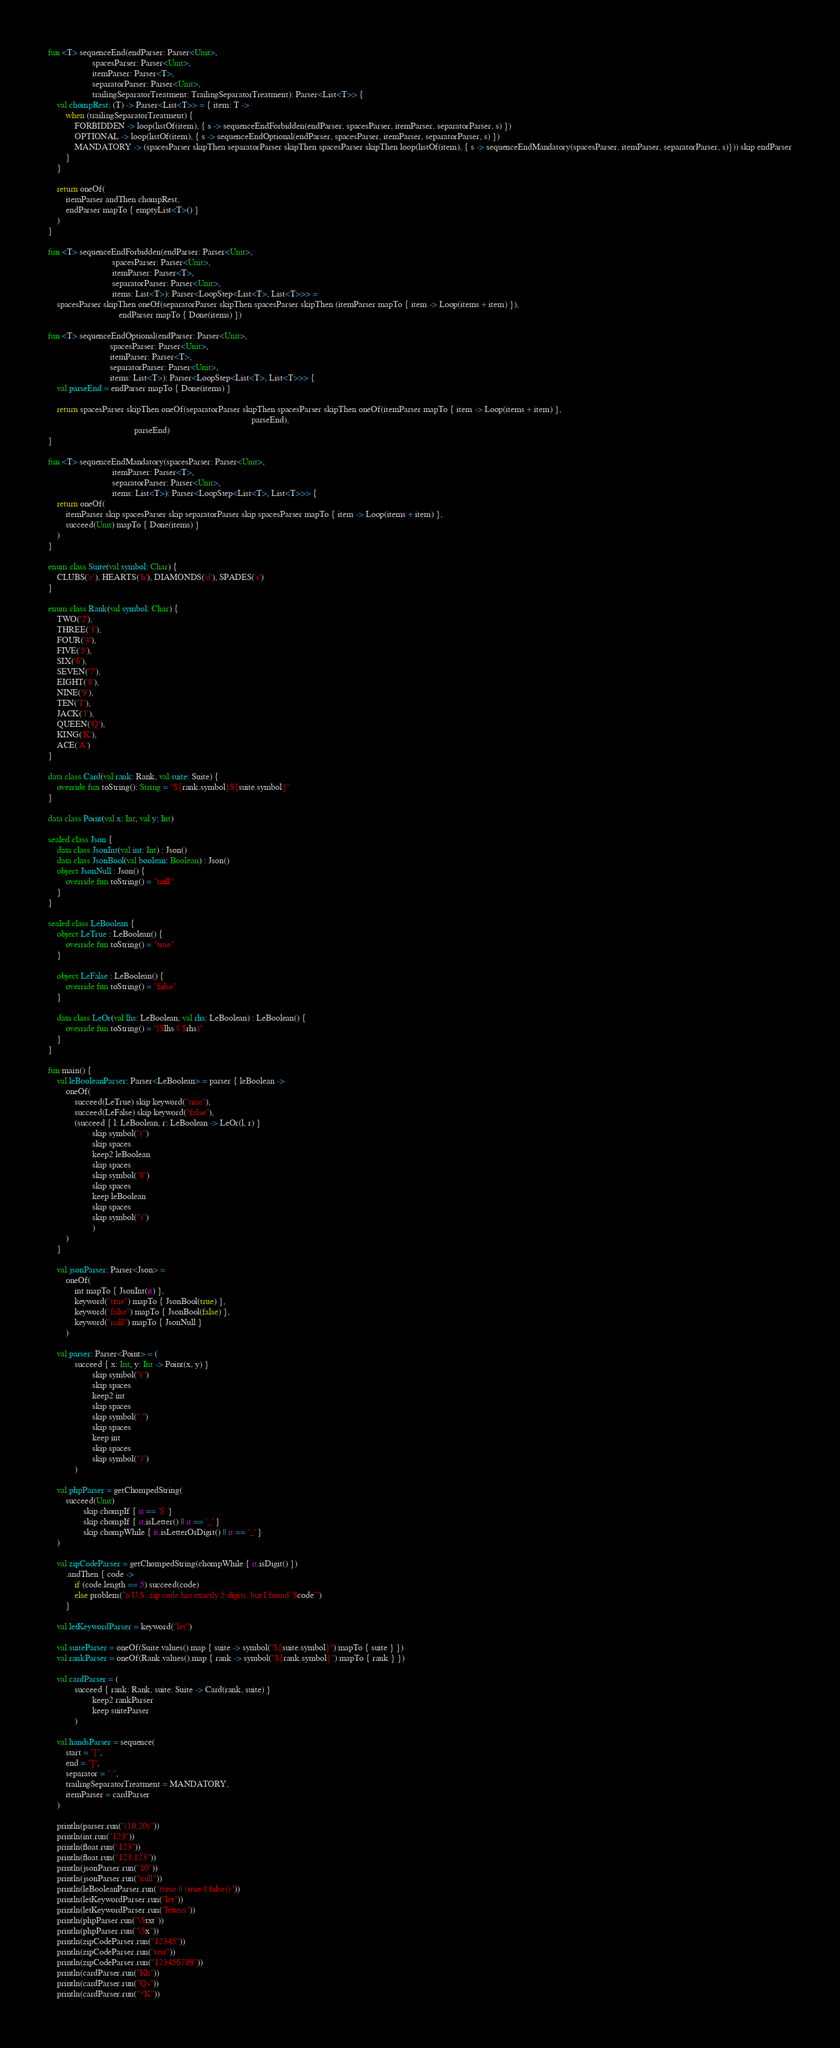<code> <loc_0><loc_0><loc_500><loc_500><_Kotlin_>fun <T> sequenceEnd(endParser: Parser<Unit>,
                    spacesParser: Parser<Unit>,
                    itemParser: Parser<T>,
                    separatorParser: Parser<Unit>,
                    trailingSeparatorTreatment: TrailingSeparatorTreatment): Parser<List<T>> {
    val chompRest: (T) -> Parser<List<T>> = { item: T ->
        when (trailingSeparatorTreatment) {
            FORBIDDEN -> loop(listOf(item), { s -> sequenceEndForbidden(endParser, spacesParser, itemParser, separatorParser, s) })
            OPTIONAL -> loop(listOf(item), { s -> sequenceEndOptional(endParser, spacesParser, itemParser, separatorParser, s) })
            MANDATORY -> (spacesParser skipThen separatorParser skipThen spacesParser skipThen loop(listOf(item), { s -> sequenceEndMandatory(spacesParser, itemParser, separatorParser, s)})) skip endParser
        }
    }

    return oneOf(
        itemParser andThen chompRest,
        endParser mapTo { emptyList<T>() }
    )
}

fun <T> sequenceEndForbidden(endParser: Parser<Unit>,
                             spacesParser: Parser<Unit>,
                             itemParser: Parser<T>,
                             separatorParser: Parser<Unit>,
                             items: List<T>): Parser<LoopStep<List<T>, List<T>>> =
    spacesParser skipThen oneOf(separatorParser skipThen spacesParser skipThen (itemParser mapTo { item -> Loop(items + item) }),
                                endParser mapTo { Done(items) })

fun <T> sequenceEndOptional(endParser: Parser<Unit>,
                            spacesParser: Parser<Unit>,
                            itemParser: Parser<T>,
                            separatorParser: Parser<Unit>,
                            items: List<T>): Parser<LoopStep<List<T>, List<T>>> {
    val parseEnd = endParser mapTo { Done(items) }

    return spacesParser skipThen oneOf(separatorParser skipThen spacesParser skipThen oneOf(itemParser mapTo { item -> Loop(items + item) },
                                                                                            parseEnd),
                                       parseEnd)
}

fun <T> sequenceEndMandatory(spacesParser: Parser<Unit>,
                             itemParser: Parser<T>,
                             separatorParser: Parser<Unit>,
                             items: List<T>): Parser<LoopStep<List<T>, List<T>>> {
    return oneOf(
        itemParser skip spacesParser skip separatorParser skip spacesParser mapTo { item -> Loop(items + item) },
        succeed(Unit) mapTo { Done(items) }
    )
}

enum class Suite(val symbol: Char) {
    CLUBS('c'), HEARTS('h'), DIAMONDS('d'), SPADES('s')
}

enum class Rank(val symbol: Char) {
    TWO('2'),
    THREE('3'),
    FOUR('4'),
    FIVE('5'),
    SIX('6'),
    SEVEN('7'),
    EIGHT('8'),
    NINE('9'),
    TEN('T'),
    JACK('J'),
    QUEEN('Q'),
    KING('K'),
    ACE('A')
}

data class Card(val rank: Rank, val suite: Suite) {
    override fun toString(): String = "${rank.symbol}${suite.symbol}"
}

data class Point(val x: Int, val y: Int)

sealed class Json {
    data class JsonInt(val int: Int) : Json()
    data class JsonBool(val boolean: Boolean) : Json()
    object JsonNull : Json() {
        override fun toString() = "null"
    }
}

sealed class LeBoolean {
    object LeTrue : LeBoolean() {
        override fun toString() = "true"
    }

    object LeFalse : LeBoolean() {
        override fun toString() = "false"
    }

    data class LeOr(val lhs: LeBoolean, val rhs: LeBoolean) : LeBoolean() {
        override fun toString() = "($lhs || $rhs)"
    }
}

fun main() {
    val leBooleanParser: Parser<LeBoolean> = parser { leBoolean ->
        oneOf(
            succeed(LeTrue) skip keyword("true"),
            succeed(LeFalse) skip keyword("false"),
            (succeed { l: LeBoolean, r: LeBoolean -> LeOr(l, r) }
                    skip symbol("(")
                    skip spaces
                    keep2 leBoolean
                    skip spaces
                    skip symbol("||")
                    skip spaces
                    keep leBoolean
                    skip spaces
                    skip symbol(")")
                    )
        )
    }

    val jsonParser: Parser<Json> =
        oneOf(
            int mapTo { JsonInt(it) },
            keyword("true") mapTo { JsonBool(true) },
            keyword("false") mapTo { JsonBool(false) },
            keyword("null") mapTo { JsonNull }
        )

    val parser: Parser<Point> = (
            succeed { x: Int, y: Int -> Point(x, y) }
                    skip symbol("(")
                    skip spaces
                    keep2 int
                    skip spaces
                    skip symbol(",")
                    skip spaces
                    keep int
                    skip spaces
                    skip symbol(")")
            )

    val phpParser = getChompedString(
        succeed(Unit)
                skip chompIf { it == '$' }
                skip chompIf { it.isLetter() || it == '_' }
                skip chompWhile { it.isLetterOrDigit() || it == '_' }
    )

    val zipCodeParser = getChompedString(chompWhile { it.isDigit() })
        .andThen { code ->
            if (code.length == 5) succeed(code)
            else problem("a U.S. zip code has exactly 5 digits, but I found '$code'")
        }

    val letKeywordParser = keyword("let")

    val suiteParser = oneOf(Suite.values().map { suite -> symbol("${suite.symbol}") mapTo { suite } })
    val rankParser = oneOf(Rank.values().map { rank -> symbol("${rank.symbol}") mapTo { rank } })

    val cardParser = (
            succeed { rank: Rank, suite: Suite -> Card(rank, suite) }
                    keep2 rankParser
                    keep suiteParser
            )

    val handsParser = sequence(
        start = "[",
        end = "]",
        separator = ",",
        trailingSeparatorTreatment = MANDATORY,
        itemParser = cardParser
    )

    println(parser.run("(10,20)"))
    println(int.run("123"))
    println(float.run("123"))
    println(float.run("123.123"))
    println(jsonParser.run("10"))
    println(jsonParser.run("null"))
    println(leBooleanParser.run("(true || (true || false))"))
    println(letKeywordParser.run("let"))
    println(letKeywordParser.run("letters"))
    println(phpParser.run("\$txt"))
    println(phpParser.run("\$x"))
    println(zipCodeParser.run("12345"))
    println(zipCodeParser.run("test"))
    println(zipCodeParser.run("123456789"))
    println(cardParser.run("Kh"))
    println(cardParser.run("Qs"))
    println(cardParser.run("*K"))</code> 